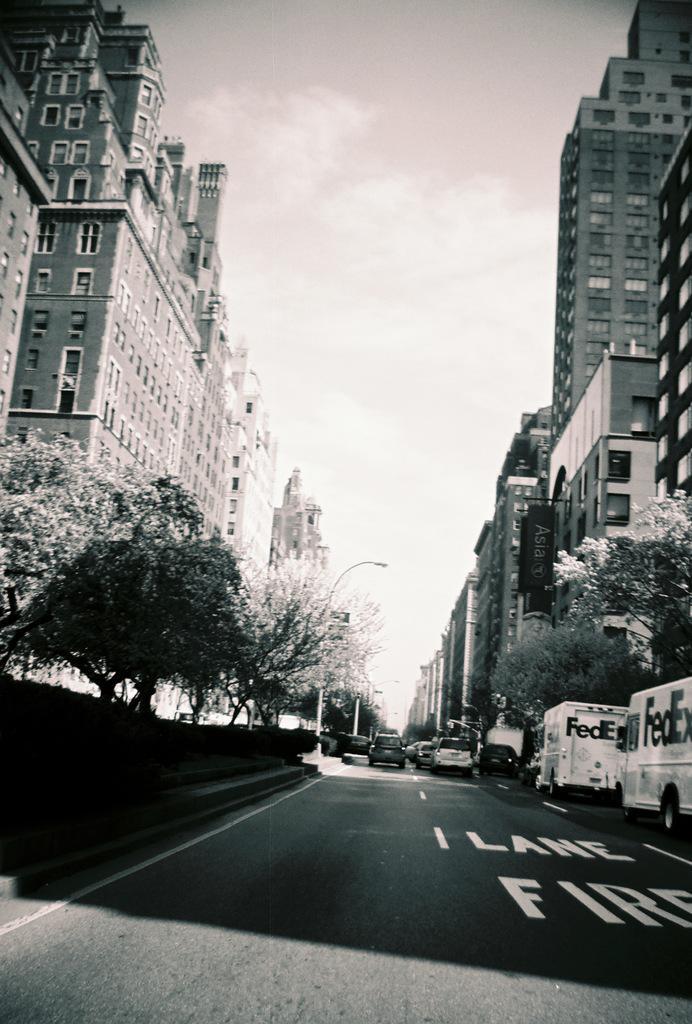In one or two sentences, can you explain what this image depicts? In this picture there are buildings and trees and there are street lights and there are vehicles on the road. At the top there is sky and there are clouds. At the bottom there is text on the road. 